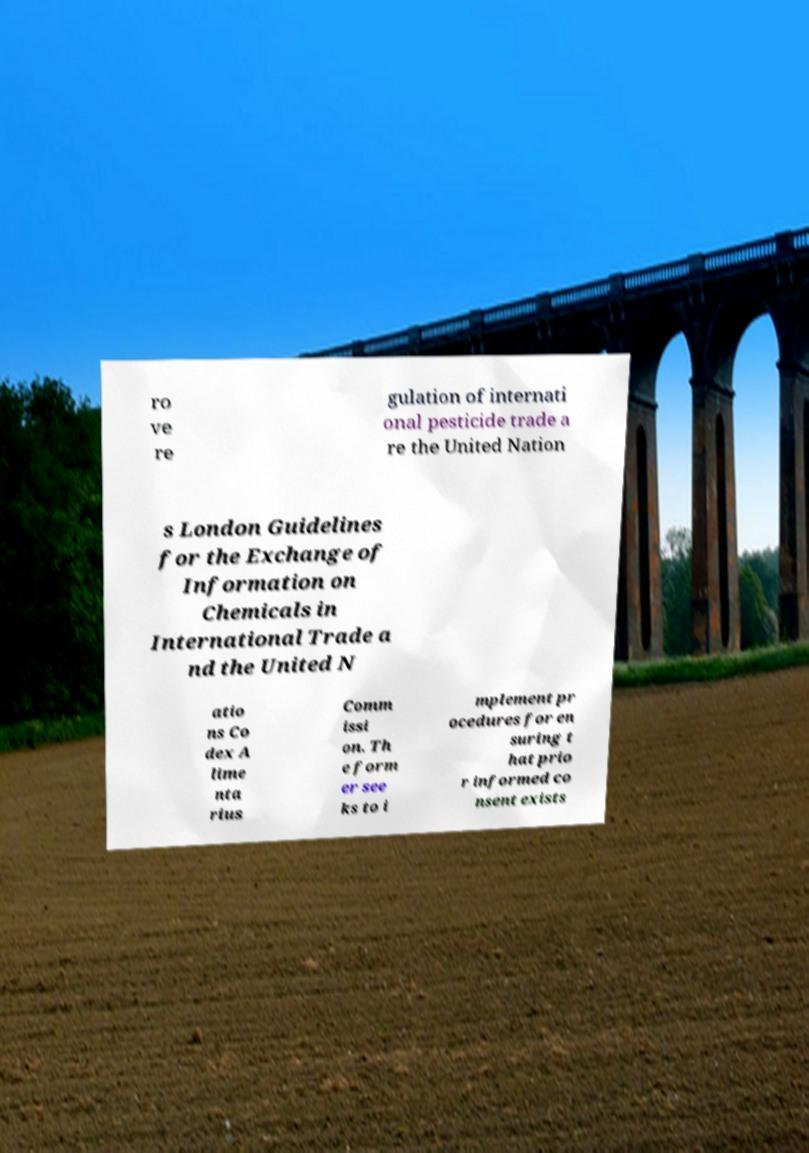I need the written content from this picture converted into text. Can you do that? ro ve re gulation of internati onal pesticide trade a re the United Nation s London Guidelines for the Exchange of Information on Chemicals in International Trade a nd the United N atio ns Co dex A lime nta rius Comm issi on. Th e form er see ks to i mplement pr ocedures for en suring t hat prio r informed co nsent exists 